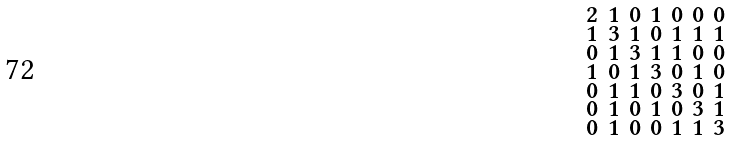<formula> <loc_0><loc_0><loc_500><loc_500>\begin{smallmatrix} 2 & 1 & 0 & 1 & 0 & 0 & 0 \\ 1 & 3 & 1 & 0 & 1 & 1 & 1 \\ 0 & 1 & 3 & 1 & 1 & 0 & 0 \\ 1 & 0 & 1 & 3 & 0 & 1 & 0 \\ 0 & 1 & 1 & 0 & 3 & 0 & 1 \\ 0 & 1 & 0 & 1 & 0 & 3 & 1 \\ 0 & 1 & 0 & 0 & 1 & 1 & 3 \end{smallmatrix}</formula> 